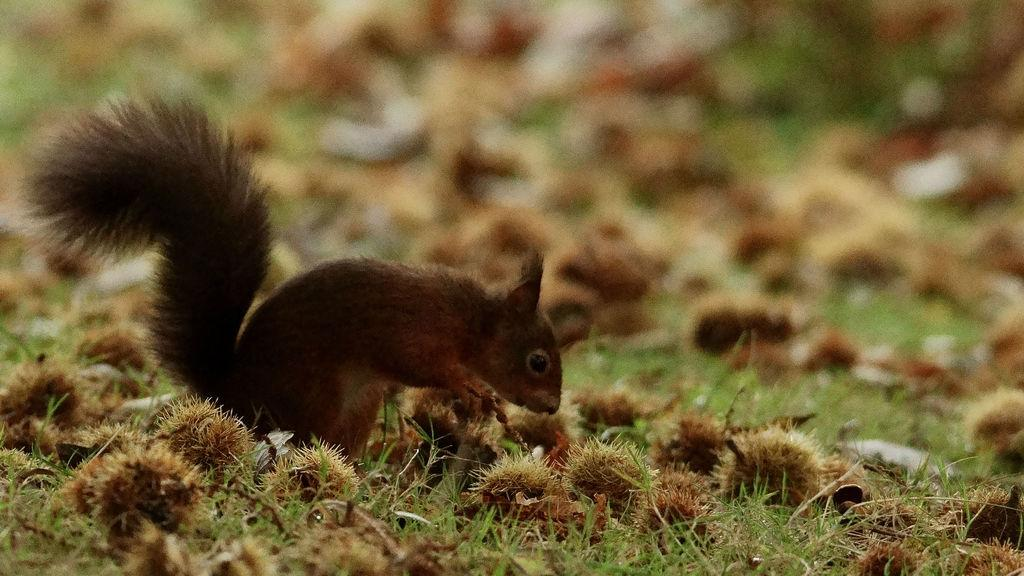What type of animal is in the image? There is a squirrel in the image. Where is the squirrel located? The squirrel is on the ground. What is the ground covered with? The ground is covered with grass. What type of books can be seen in the image? There are no books present in the image; it features a squirrel on the ground with grass-covered ground. What type of plough is being used by the squirrel in the image? There is no plough present in the image, and the squirrel is not using any farming equipment. 